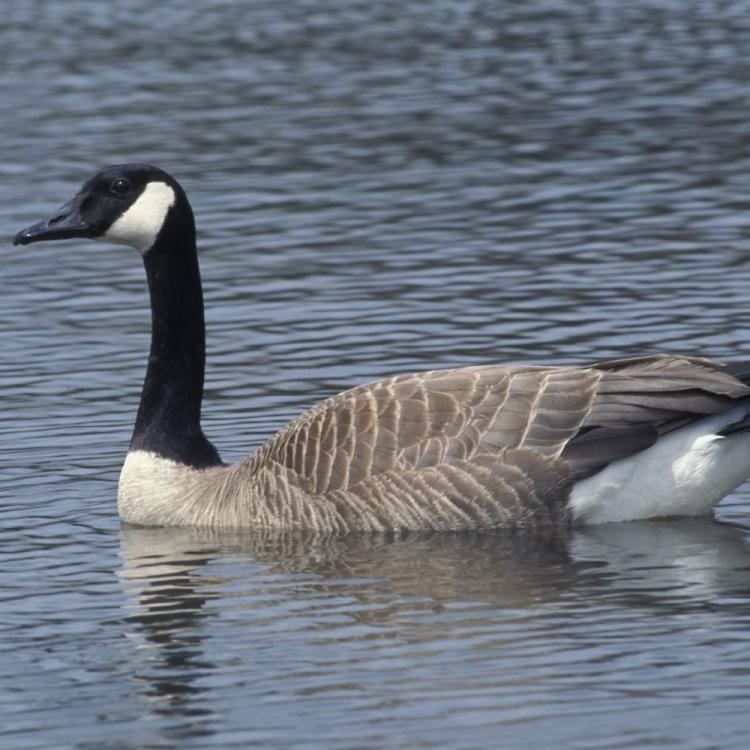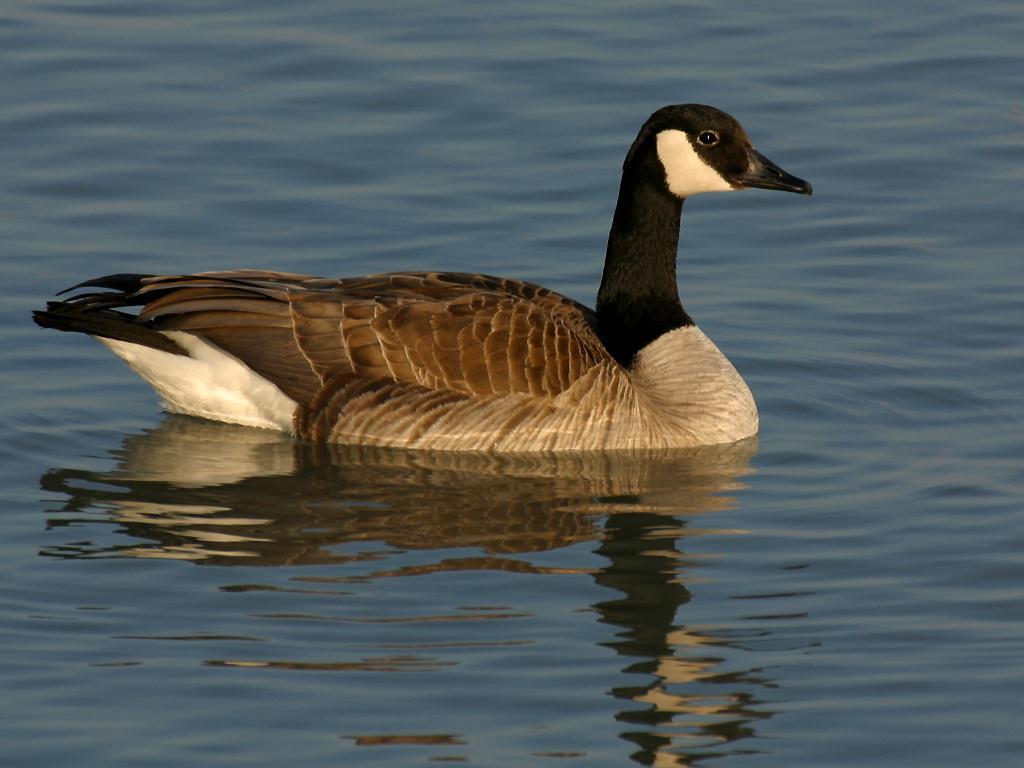The first image is the image on the left, the second image is the image on the right. Examine the images to the left and right. Is the description "The left image contains exactly two ducks both swimming in the same direction." accurate? Answer yes or no. No. The first image is the image on the left, the second image is the image on the right. Examine the images to the left and right. Is the description "An image shows exactly two black-necked geese on water, both heading rightward." accurate? Answer yes or no. No. The first image is the image on the left, the second image is the image on the right. Given the left and right images, does the statement "The image on the right has no more than one duck and it's body is facing right." hold true? Answer yes or no. Yes. The first image is the image on the left, the second image is the image on the right. Evaluate the accuracy of this statement regarding the images: "There are two adult Canadian geese floating on water". Is it true? Answer yes or no. Yes. 